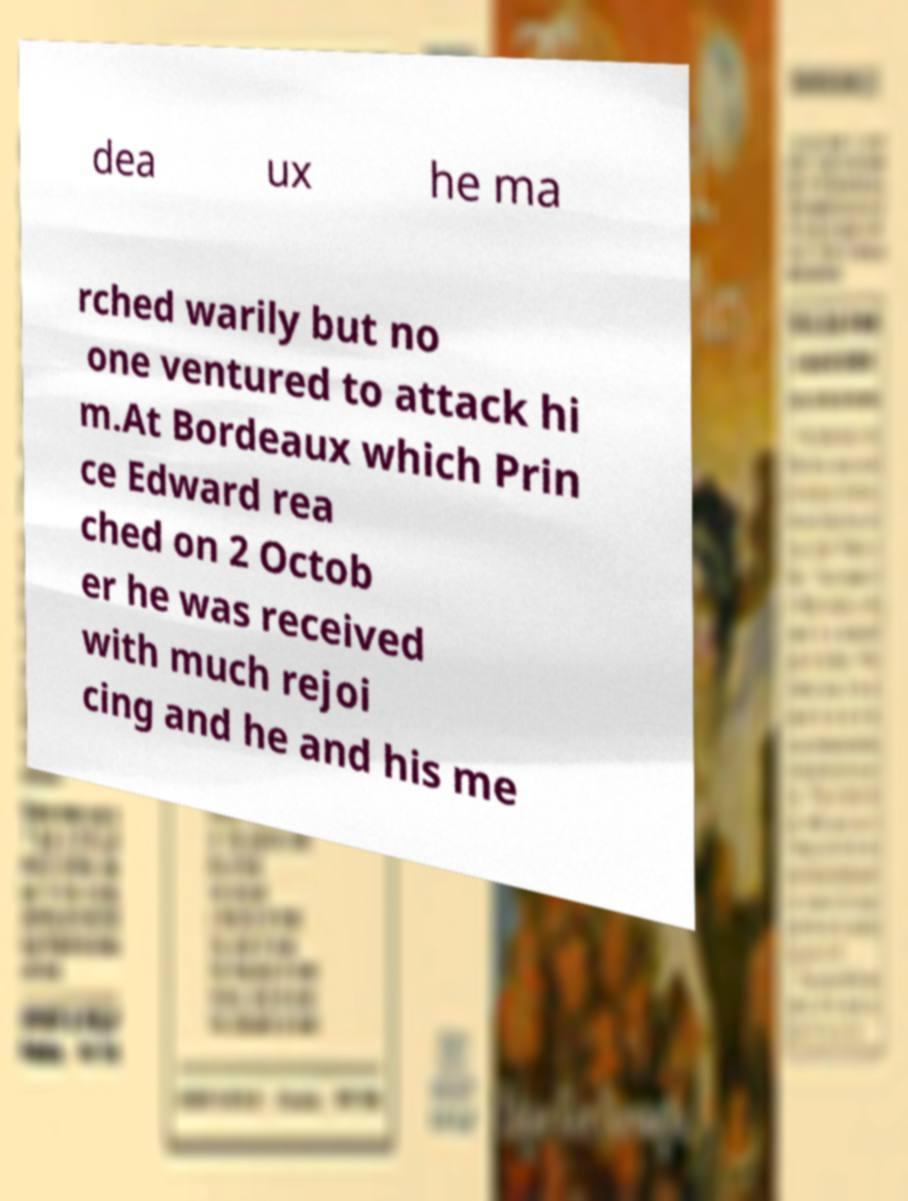Can you read and provide the text displayed in the image?This photo seems to have some interesting text. Can you extract and type it out for me? dea ux he ma rched warily but no one ventured to attack hi m.At Bordeaux which Prin ce Edward rea ched on 2 Octob er he was received with much rejoi cing and he and his me 